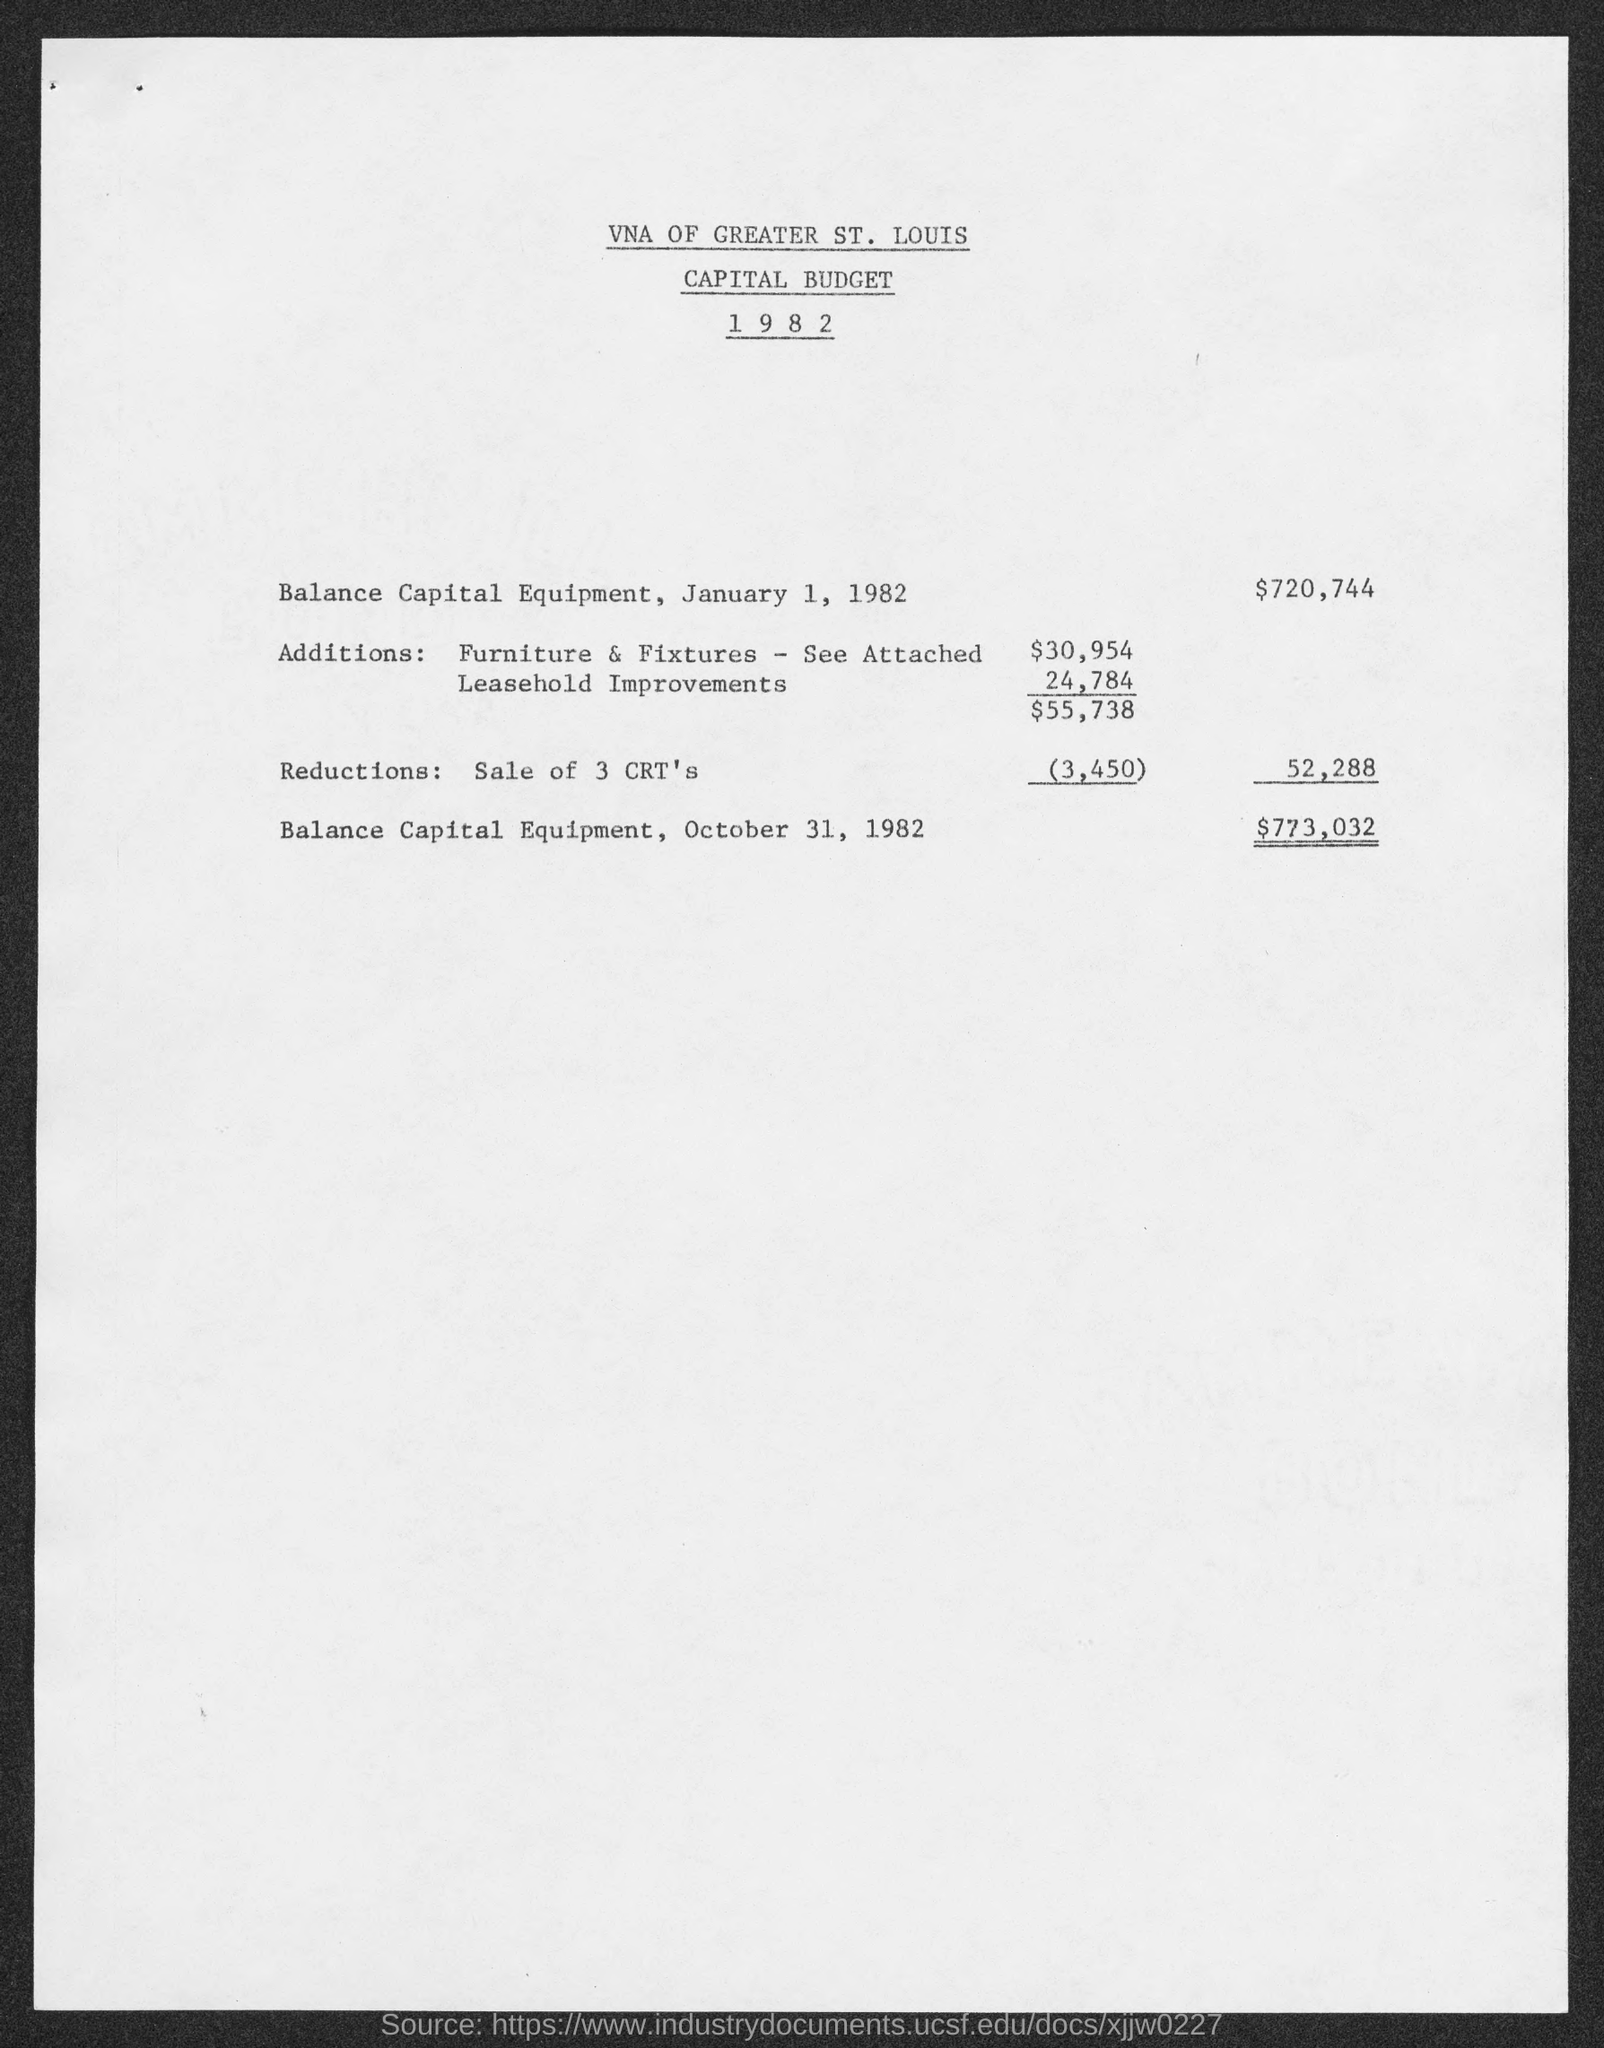Draw attention to some important aspects in this diagram. This document pertains to a capital budget. As of January 1, 1982, the balance of capital equipment was $720,744. 